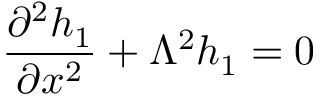<formula> <loc_0><loc_0><loc_500><loc_500>\frac { \partial ^ { 2 } h _ { 1 } } { \partial x ^ { 2 } } + \Lambda ^ { 2 } h _ { 1 } = 0</formula> 